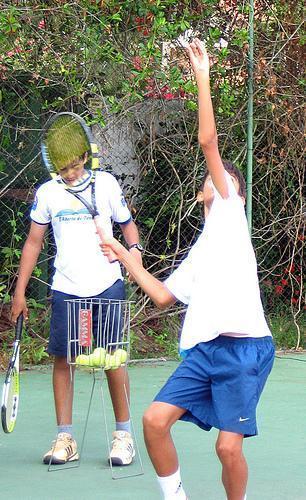How many people can be seen practicing?
Give a very brief answer. 2. 